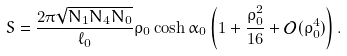Convert formula to latex. <formula><loc_0><loc_0><loc_500><loc_500>S = \frac { 2 \pi \sqrt { N _ { 1 } N _ { 4 } N _ { 0 } } } { \ell _ { 0 } } \rho _ { 0 } \cosh \alpha _ { 0 } \left ( 1 + \frac { \rho _ { 0 } ^ { 2 } } { 1 6 } + \mathcal { O } ( \rho _ { 0 } ^ { 4 } ) \right ) .</formula> 